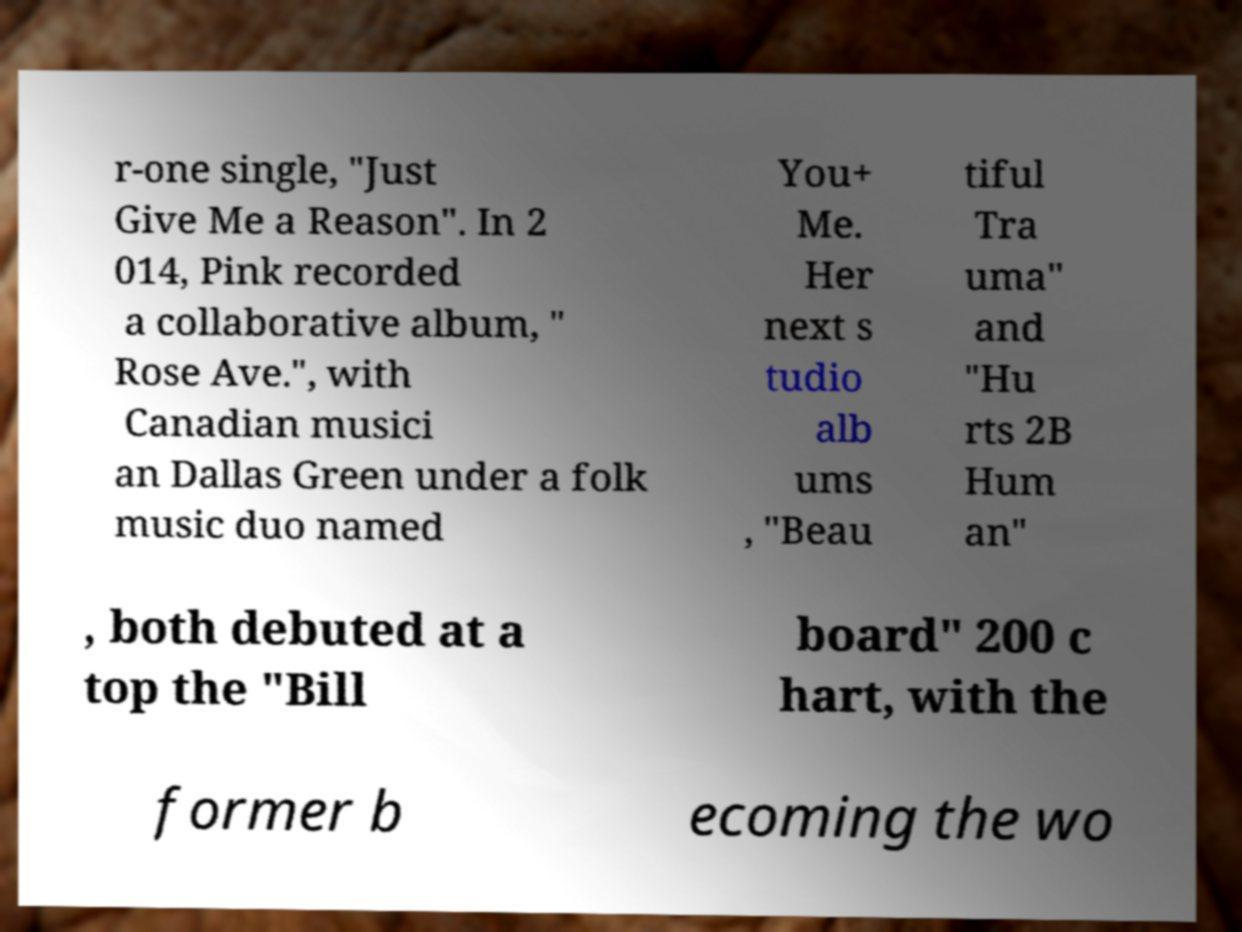There's text embedded in this image that I need extracted. Can you transcribe it verbatim? r-one single, "Just Give Me a Reason". In 2 014, Pink recorded a collaborative album, " Rose Ave.", with Canadian musici an Dallas Green under a folk music duo named You+ Me. Her next s tudio alb ums , "Beau tiful Tra uma" and "Hu rts 2B Hum an" , both debuted at a top the "Bill board" 200 c hart, with the former b ecoming the wo 